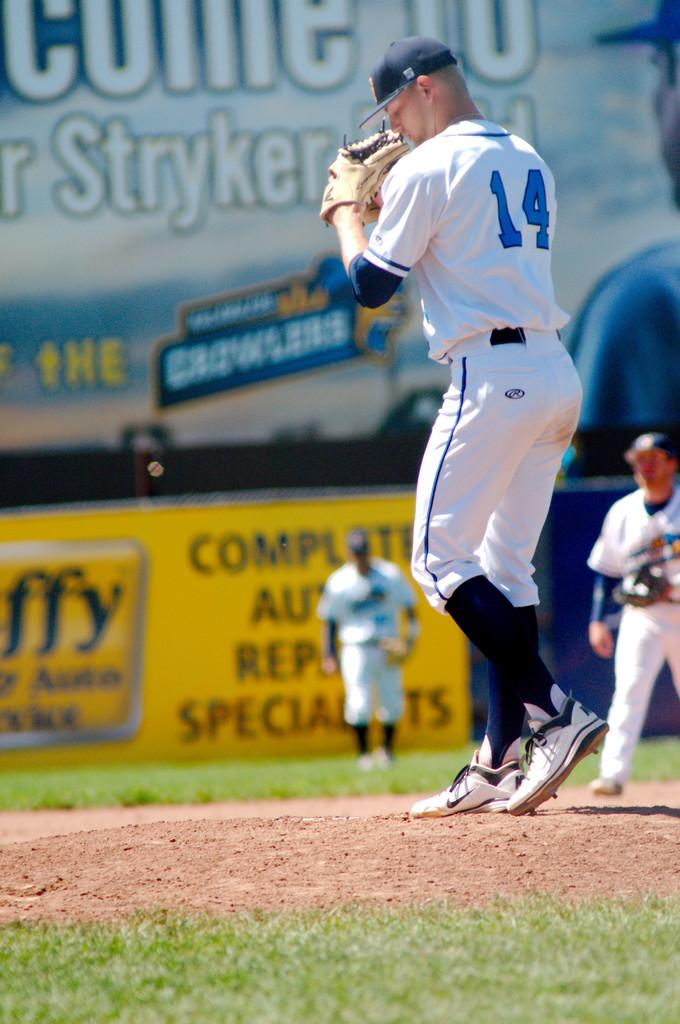<image>
Offer a succinct explanation of the picture presented. PLayer number 14 in a white baseball uniform prepares to pitch the ball from the mound. 